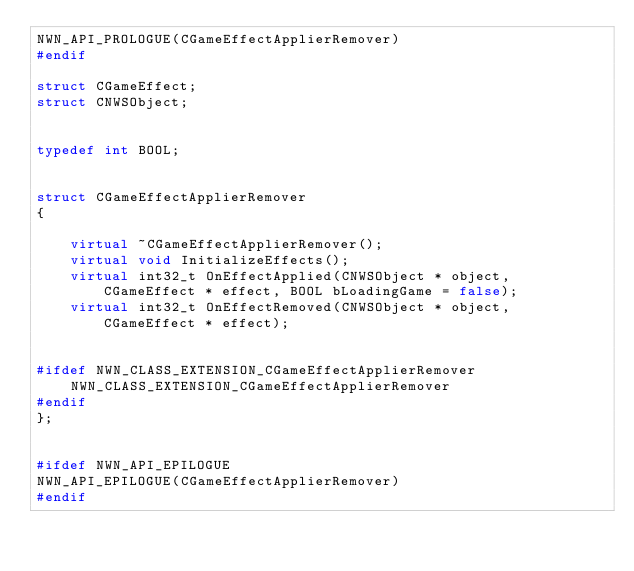Convert code to text. <code><loc_0><loc_0><loc_500><loc_500><_C++_>NWN_API_PROLOGUE(CGameEffectApplierRemover)
#endif

struct CGameEffect;
struct CNWSObject;


typedef int BOOL;


struct CGameEffectApplierRemover
{

    virtual ~CGameEffectApplierRemover();
    virtual void InitializeEffects();
    virtual int32_t OnEffectApplied(CNWSObject * object, CGameEffect * effect, BOOL bLoadingGame = false);
    virtual int32_t OnEffectRemoved(CNWSObject * object, CGameEffect * effect);


#ifdef NWN_CLASS_EXTENSION_CGameEffectApplierRemover
    NWN_CLASS_EXTENSION_CGameEffectApplierRemover
#endif
};


#ifdef NWN_API_EPILOGUE
NWN_API_EPILOGUE(CGameEffectApplierRemover)
#endif

</code> 